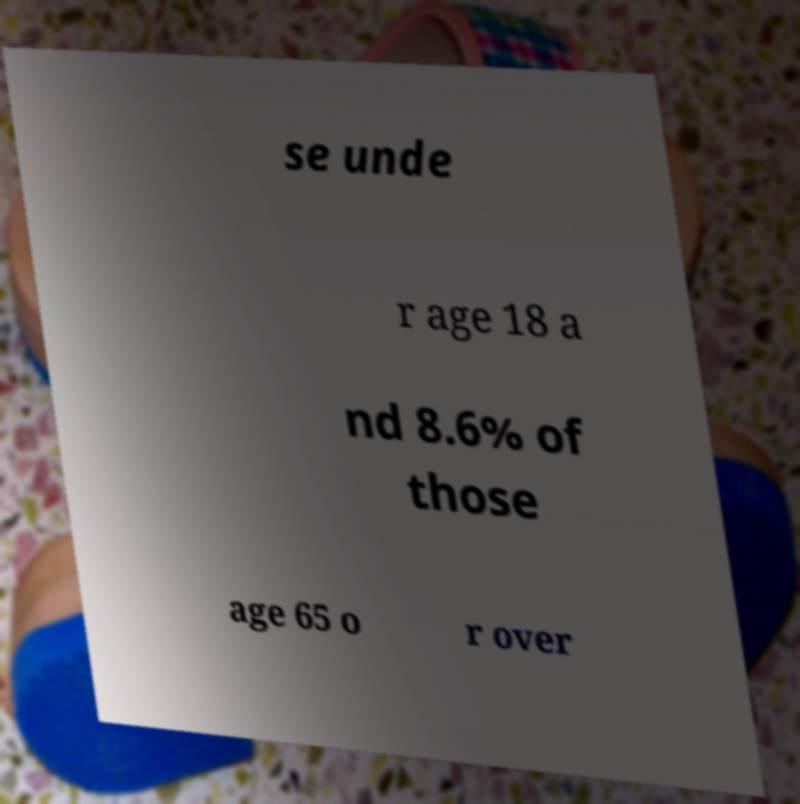Could you assist in decoding the text presented in this image and type it out clearly? se unde r age 18 a nd 8.6% of those age 65 o r over 